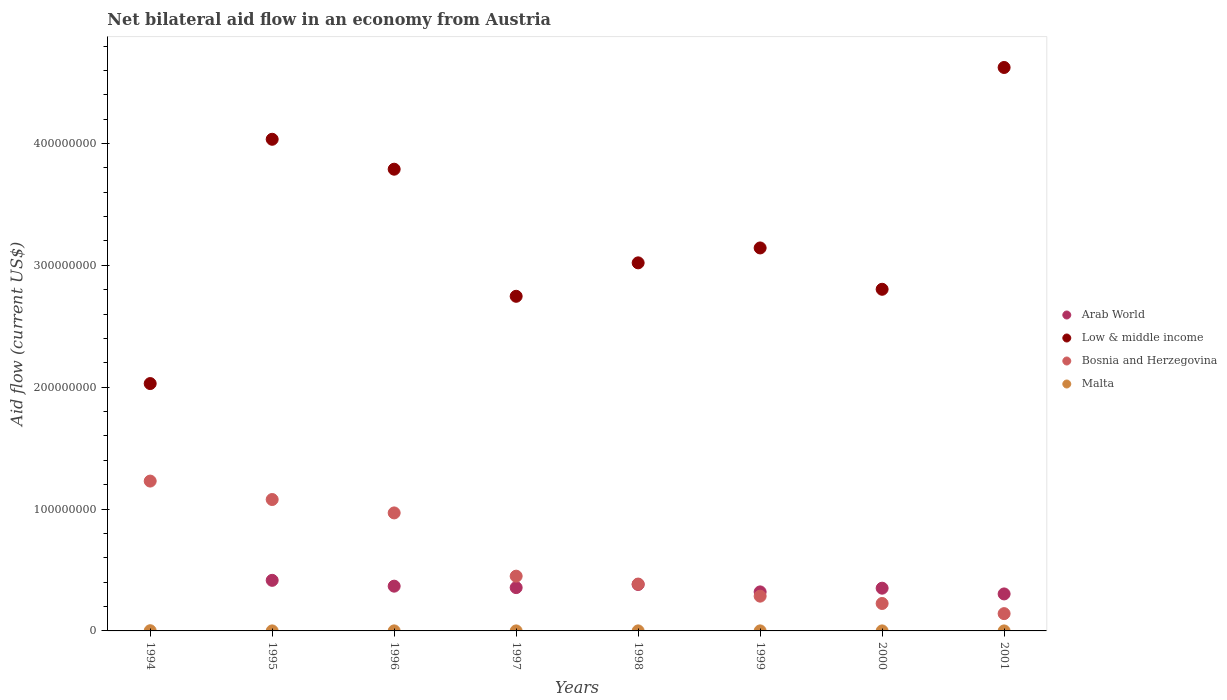What is the net bilateral aid flow in Low & middle income in 1996?
Your response must be concise. 3.79e+08. Across all years, what is the maximum net bilateral aid flow in Low & middle income?
Keep it short and to the point. 4.62e+08. Across all years, what is the minimum net bilateral aid flow in Low & middle income?
Your answer should be compact. 2.03e+08. What is the total net bilateral aid flow in Malta in the graph?
Offer a very short reply. 3.30e+05. What is the difference between the net bilateral aid flow in Malta in 1994 and that in 2001?
Offer a terse response. 1.50e+05. What is the difference between the net bilateral aid flow in Bosnia and Herzegovina in 1997 and the net bilateral aid flow in Low & middle income in 1995?
Your response must be concise. -3.59e+08. What is the average net bilateral aid flow in Low & middle income per year?
Your answer should be very brief. 3.27e+08. In the year 1996, what is the difference between the net bilateral aid flow in Malta and net bilateral aid flow in Bosnia and Herzegovina?
Give a very brief answer. -9.68e+07. What is the ratio of the net bilateral aid flow in Low & middle income in 1996 to that in 1997?
Your answer should be compact. 1.38. Is the net bilateral aid flow in Malta in 1999 less than that in 2000?
Your response must be concise. No. What is the difference between the highest and the second highest net bilateral aid flow in Bosnia and Herzegovina?
Give a very brief answer. 1.51e+07. What is the difference between the highest and the lowest net bilateral aid flow in Malta?
Provide a succinct answer. 1.50e+05. Is it the case that in every year, the sum of the net bilateral aid flow in Low & middle income and net bilateral aid flow in Bosnia and Herzegovina  is greater than the net bilateral aid flow in Malta?
Make the answer very short. Yes. What is the title of the graph?
Ensure brevity in your answer.  Net bilateral aid flow in an economy from Austria. What is the label or title of the X-axis?
Keep it short and to the point. Years. What is the Aid flow (current US$) of Low & middle income in 1994?
Keep it short and to the point. 2.03e+08. What is the Aid flow (current US$) of Bosnia and Herzegovina in 1994?
Make the answer very short. 1.23e+08. What is the Aid flow (current US$) of Malta in 1994?
Offer a terse response. 1.60e+05. What is the Aid flow (current US$) of Arab World in 1995?
Keep it short and to the point. 4.15e+07. What is the Aid flow (current US$) in Low & middle income in 1995?
Provide a short and direct response. 4.03e+08. What is the Aid flow (current US$) in Bosnia and Herzegovina in 1995?
Your answer should be very brief. 1.08e+08. What is the Aid flow (current US$) of Malta in 1995?
Your answer should be very brief. 2.00e+04. What is the Aid flow (current US$) of Arab World in 1996?
Your answer should be very brief. 3.67e+07. What is the Aid flow (current US$) of Low & middle income in 1996?
Keep it short and to the point. 3.79e+08. What is the Aid flow (current US$) of Bosnia and Herzegovina in 1996?
Ensure brevity in your answer.  9.68e+07. What is the Aid flow (current US$) of Arab World in 1997?
Offer a very short reply. 3.56e+07. What is the Aid flow (current US$) in Low & middle income in 1997?
Your answer should be very brief. 2.75e+08. What is the Aid flow (current US$) of Bosnia and Herzegovina in 1997?
Provide a succinct answer. 4.49e+07. What is the Aid flow (current US$) in Malta in 1997?
Provide a succinct answer. 2.00e+04. What is the Aid flow (current US$) of Arab World in 1998?
Give a very brief answer. 3.81e+07. What is the Aid flow (current US$) of Low & middle income in 1998?
Your answer should be very brief. 3.02e+08. What is the Aid flow (current US$) of Bosnia and Herzegovina in 1998?
Your answer should be very brief. 3.85e+07. What is the Aid flow (current US$) of Arab World in 1999?
Provide a succinct answer. 3.20e+07. What is the Aid flow (current US$) of Low & middle income in 1999?
Make the answer very short. 3.14e+08. What is the Aid flow (current US$) in Bosnia and Herzegovina in 1999?
Your answer should be compact. 2.85e+07. What is the Aid flow (current US$) in Arab World in 2000?
Ensure brevity in your answer.  3.51e+07. What is the Aid flow (current US$) of Low & middle income in 2000?
Offer a very short reply. 2.80e+08. What is the Aid flow (current US$) of Bosnia and Herzegovina in 2000?
Give a very brief answer. 2.25e+07. What is the Aid flow (current US$) in Malta in 2000?
Offer a terse response. 2.00e+04. What is the Aid flow (current US$) of Arab World in 2001?
Offer a terse response. 3.04e+07. What is the Aid flow (current US$) in Low & middle income in 2001?
Provide a succinct answer. 4.62e+08. What is the Aid flow (current US$) of Bosnia and Herzegovina in 2001?
Offer a terse response. 1.42e+07. What is the Aid flow (current US$) in Malta in 2001?
Offer a very short reply. 10000. Across all years, what is the maximum Aid flow (current US$) of Arab World?
Keep it short and to the point. 4.15e+07. Across all years, what is the maximum Aid flow (current US$) of Low & middle income?
Offer a terse response. 4.62e+08. Across all years, what is the maximum Aid flow (current US$) in Bosnia and Herzegovina?
Your answer should be compact. 1.23e+08. Across all years, what is the maximum Aid flow (current US$) in Malta?
Offer a terse response. 1.60e+05. Across all years, what is the minimum Aid flow (current US$) in Low & middle income?
Your answer should be compact. 2.03e+08. Across all years, what is the minimum Aid flow (current US$) of Bosnia and Herzegovina?
Your response must be concise. 1.42e+07. Across all years, what is the minimum Aid flow (current US$) in Malta?
Your answer should be compact. 10000. What is the total Aid flow (current US$) in Arab World in the graph?
Provide a succinct answer. 2.49e+08. What is the total Aid flow (current US$) of Low & middle income in the graph?
Provide a succinct answer. 2.62e+09. What is the total Aid flow (current US$) of Bosnia and Herzegovina in the graph?
Give a very brief answer. 4.76e+08. What is the difference between the Aid flow (current US$) of Low & middle income in 1994 and that in 1995?
Make the answer very short. -2.00e+08. What is the difference between the Aid flow (current US$) in Bosnia and Herzegovina in 1994 and that in 1995?
Provide a succinct answer. 1.51e+07. What is the difference between the Aid flow (current US$) in Low & middle income in 1994 and that in 1996?
Your answer should be very brief. -1.76e+08. What is the difference between the Aid flow (current US$) of Bosnia and Herzegovina in 1994 and that in 1996?
Offer a very short reply. 2.61e+07. What is the difference between the Aid flow (current US$) of Malta in 1994 and that in 1996?
Make the answer very short. 1.20e+05. What is the difference between the Aid flow (current US$) in Low & middle income in 1994 and that in 1997?
Provide a succinct answer. -7.16e+07. What is the difference between the Aid flow (current US$) of Bosnia and Herzegovina in 1994 and that in 1997?
Offer a terse response. 7.80e+07. What is the difference between the Aid flow (current US$) of Low & middle income in 1994 and that in 1998?
Your response must be concise. -9.91e+07. What is the difference between the Aid flow (current US$) in Bosnia and Herzegovina in 1994 and that in 1998?
Your response must be concise. 8.45e+07. What is the difference between the Aid flow (current US$) in Malta in 1994 and that in 1998?
Offer a terse response. 1.30e+05. What is the difference between the Aid flow (current US$) of Low & middle income in 1994 and that in 1999?
Your answer should be compact. -1.11e+08. What is the difference between the Aid flow (current US$) of Bosnia and Herzegovina in 1994 and that in 1999?
Offer a terse response. 9.44e+07. What is the difference between the Aid flow (current US$) in Low & middle income in 1994 and that in 2000?
Provide a short and direct response. -7.74e+07. What is the difference between the Aid flow (current US$) in Bosnia and Herzegovina in 1994 and that in 2000?
Your answer should be very brief. 1.00e+08. What is the difference between the Aid flow (current US$) of Malta in 1994 and that in 2000?
Offer a very short reply. 1.40e+05. What is the difference between the Aid flow (current US$) of Low & middle income in 1994 and that in 2001?
Offer a terse response. -2.59e+08. What is the difference between the Aid flow (current US$) in Bosnia and Herzegovina in 1994 and that in 2001?
Ensure brevity in your answer.  1.09e+08. What is the difference between the Aid flow (current US$) of Malta in 1994 and that in 2001?
Provide a short and direct response. 1.50e+05. What is the difference between the Aid flow (current US$) in Arab World in 1995 and that in 1996?
Give a very brief answer. 4.78e+06. What is the difference between the Aid flow (current US$) in Low & middle income in 1995 and that in 1996?
Offer a very short reply. 2.46e+07. What is the difference between the Aid flow (current US$) of Bosnia and Herzegovina in 1995 and that in 1996?
Provide a short and direct response. 1.10e+07. What is the difference between the Aid flow (current US$) of Malta in 1995 and that in 1996?
Your response must be concise. -2.00e+04. What is the difference between the Aid flow (current US$) of Arab World in 1995 and that in 1997?
Ensure brevity in your answer.  5.96e+06. What is the difference between the Aid flow (current US$) of Low & middle income in 1995 and that in 1997?
Your response must be concise. 1.29e+08. What is the difference between the Aid flow (current US$) in Bosnia and Herzegovina in 1995 and that in 1997?
Keep it short and to the point. 6.29e+07. What is the difference between the Aid flow (current US$) of Arab World in 1995 and that in 1998?
Keep it short and to the point. 3.39e+06. What is the difference between the Aid flow (current US$) in Low & middle income in 1995 and that in 1998?
Ensure brevity in your answer.  1.01e+08. What is the difference between the Aid flow (current US$) of Bosnia and Herzegovina in 1995 and that in 1998?
Your answer should be compact. 6.94e+07. What is the difference between the Aid flow (current US$) of Malta in 1995 and that in 1998?
Keep it short and to the point. -10000. What is the difference between the Aid flow (current US$) in Arab World in 1995 and that in 1999?
Give a very brief answer. 9.48e+06. What is the difference between the Aid flow (current US$) of Low & middle income in 1995 and that in 1999?
Give a very brief answer. 8.92e+07. What is the difference between the Aid flow (current US$) of Bosnia and Herzegovina in 1995 and that in 1999?
Ensure brevity in your answer.  7.93e+07. What is the difference between the Aid flow (current US$) of Arab World in 1995 and that in 2000?
Offer a very short reply. 6.44e+06. What is the difference between the Aid flow (current US$) in Low & middle income in 1995 and that in 2000?
Give a very brief answer. 1.23e+08. What is the difference between the Aid flow (current US$) in Bosnia and Herzegovina in 1995 and that in 2000?
Ensure brevity in your answer.  8.53e+07. What is the difference between the Aid flow (current US$) in Malta in 1995 and that in 2000?
Your answer should be compact. 0. What is the difference between the Aid flow (current US$) of Arab World in 1995 and that in 2001?
Offer a very short reply. 1.12e+07. What is the difference between the Aid flow (current US$) of Low & middle income in 1995 and that in 2001?
Make the answer very short. -5.89e+07. What is the difference between the Aid flow (current US$) in Bosnia and Herzegovina in 1995 and that in 2001?
Make the answer very short. 9.36e+07. What is the difference between the Aid flow (current US$) of Arab World in 1996 and that in 1997?
Provide a short and direct response. 1.18e+06. What is the difference between the Aid flow (current US$) in Low & middle income in 1996 and that in 1997?
Your answer should be compact. 1.04e+08. What is the difference between the Aid flow (current US$) of Bosnia and Herzegovina in 1996 and that in 1997?
Give a very brief answer. 5.19e+07. What is the difference between the Aid flow (current US$) in Malta in 1996 and that in 1997?
Offer a very short reply. 2.00e+04. What is the difference between the Aid flow (current US$) in Arab World in 1996 and that in 1998?
Give a very brief answer. -1.39e+06. What is the difference between the Aid flow (current US$) of Low & middle income in 1996 and that in 1998?
Give a very brief answer. 7.69e+07. What is the difference between the Aid flow (current US$) in Bosnia and Herzegovina in 1996 and that in 1998?
Make the answer very short. 5.84e+07. What is the difference between the Aid flow (current US$) in Arab World in 1996 and that in 1999?
Make the answer very short. 4.70e+06. What is the difference between the Aid flow (current US$) in Low & middle income in 1996 and that in 1999?
Offer a terse response. 6.46e+07. What is the difference between the Aid flow (current US$) in Bosnia and Herzegovina in 1996 and that in 1999?
Your answer should be very brief. 6.83e+07. What is the difference between the Aid flow (current US$) of Arab World in 1996 and that in 2000?
Provide a short and direct response. 1.66e+06. What is the difference between the Aid flow (current US$) in Low & middle income in 1996 and that in 2000?
Make the answer very short. 9.85e+07. What is the difference between the Aid flow (current US$) of Bosnia and Herzegovina in 1996 and that in 2000?
Make the answer very short. 7.43e+07. What is the difference between the Aid flow (current US$) of Malta in 1996 and that in 2000?
Offer a very short reply. 2.00e+04. What is the difference between the Aid flow (current US$) in Arab World in 1996 and that in 2001?
Keep it short and to the point. 6.37e+06. What is the difference between the Aid flow (current US$) in Low & middle income in 1996 and that in 2001?
Keep it short and to the point. -8.35e+07. What is the difference between the Aid flow (current US$) of Bosnia and Herzegovina in 1996 and that in 2001?
Offer a terse response. 8.26e+07. What is the difference between the Aid flow (current US$) of Arab World in 1997 and that in 1998?
Provide a succinct answer. -2.57e+06. What is the difference between the Aid flow (current US$) in Low & middle income in 1997 and that in 1998?
Provide a succinct answer. -2.74e+07. What is the difference between the Aid flow (current US$) of Bosnia and Herzegovina in 1997 and that in 1998?
Offer a very short reply. 6.48e+06. What is the difference between the Aid flow (current US$) in Arab World in 1997 and that in 1999?
Keep it short and to the point. 3.52e+06. What is the difference between the Aid flow (current US$) of Low & middle income in 1997 and that in 1999?
Make the answer very short. -3.97e+07. What is the difference between the Aid flow (current US$) in Bosnia and Herzegovina in 1997 and that in 1999?
Ensure brevity in your answer.  1.64e+07. What is the difference between the Aid flow (current US$) of Low & middle income in 1997 and that in 2000?
Make the answer very short. -5.76e+06. What is the difference between the Aid flow (current US$) of Bosnia and Herzegovina in 1997 and that in 2000?
Make the answer very short. 2.24e+07. What is the difference between the Aid flow (current US$) in Malta in 1997 and that in 2000?
Your answer should be very brief. 0. What is the difference between the Aid flow (current US$) in Arab World in 1997 and that in 2001?
Provide a short and direct response. 5.19e+06. What is the difference between the Aid flow (current US$) in Low & middle income in 1997 and that in 2001?
Provide a short and direct response. -1.88e+08. What is the difference between the Aid flow (current US$) in Bosnia and Herzegovina in 1997 and that in 2001?
Offer a very short reply. 3.08e+07. What is the difference between the Aid flow (current US$) of Arab World in 1998 and that in 1999?
Make the answer very short. 6.09e+06. What is the difference between the Aid flow (current US$) in Low & middle income in 1998 and that in 1999?
Your answer should be compact. -1.22e+07. What is the difference between the Aid flow (current US$) of Bosnia and Herzegovina in 1998 and that in 1999?
Your response must be concise. 9.93e+06. What is the difference between the Aid flow (current US$) of Malta in 1998 and that in 1999?
Your answer should be very brief. 0. What is the difference between the Aid flow (current US$) of Arab World in 1998 and that in 2000?
Make the answer very short. 3.05e+06. What is the difference between the Aid flow (current US$) of Low & middle income in 1998 and that in 2000?
Make the answer very short. 2.17e+07. What is the difference between the Aid flow (current US$) of Bosnia and Herzegovina in 1998 and that in 2000?
Give a very brief answer. 1.59e+07. What is the difference between the Aid flow (current US$) of Malta in 1998 and that in 2000?
Give a very brief answer. 10000. What is the difference between the Aid flow (current US$) in Arab World in 1998 and that in 2001?
Ensure brevity in your answer.  7.76e+06. What is the difference between the Aid flow (current US$) in Low & middle income in 1998 and that in 2001?
Your answer should be compact. -1.60e+08. What is the difference between the Aid flow (current US$) in Bosnia and Herzegovina in 1998 and that in 2001?
Give a very brief answer. 2.43e+07. What is the difference between the Aid flow (current US$) in Malta in 1998 and that in 2001?
Provide a succinct answer. 2.00e+04. What is the difference between the Aid flow (current US$) of Arab World in 1999 and that in 2000?
Provide a short and direct response. -3.04e+06. What is the difference between the Aid flow (current US$) of Low & middle income in 1999 and that in 2000?
Your answer should be very brief. 3.39e+07. What is the difference between the Aid flow (current US$) of Bosnia and Herzegovina in 1999 and that in 2000?
Give a very brief answer. 6.01e+06. What is the difference between the Aid flow (current US$) of Malta in 1999 and that in 2000?
Ensure brevity in your answer.  10000. What is the difference between the Aid flow (current US$) of Arab World in 1999 and that in 2001?
Ensure brevity in your answer.  1.67e+06. What is the difference between the Aid flow (current US$) in Low & middle income in 1999 and that in 2001?
Give a very brief answer. -1.48e+08. What is the difference between the Aid flow (current US$) of Bosnia and Herzegovina in 1999 and that in 2001?
Provide a succinct answer. 1.43e+07. What is the difference between the Aid flow (current US$) in Arab World in 2000 and that in 2001?
Provide a short and direct response. 4.71e+06. What is the difference between the Aid flow (current US$) of Low & middle income in 2000 and that in 2001?
Make the answer very short. -1.82e+08. What is the difference between the Aid flow (current US$) in Bosnia and Herzegovina in 2000 and that in 2001?
Keep it short and to the point. 8.33e+06. What is the difference between the Aid flow (current US$) in Malta in 2000 and that in 2001?
Ensure brevity in your answer.  10000. What is the difference between the Aid flow (current US$) in Low & middle income in 1994 and the Aid flow (current US$) in Bosnia and Herzegovina in 1995?
Provide a short and direct response. 9.52e+07. What is the difference between the Aid flow (current US$) in Low & middle income in 1994 and the Aid flow (current US$) in Malta in 1995?
Give a very brief answer. 2.03e+08. What is the difference between the Aid flow (current US$) of Bosnia and Herzegovina in 1994 and the Aid flow (current US$) of Malta in 1995?
Make the answer very short. 1.23e+08. What is the difference between the Aid flow (current US$) in Low & middle income in 1994 and the Aid flow (current US$) in Bosnia and Herzegovina in 1996?
Your answer should be compact. 1.06e+08. What is the difference between the Aid flow (current US$) of Low & middle income in 1994 and the Aid flow (current US$) of Malta in 1996?
Provide a succinct answer. 2.03e+08. What is the difference between the Aid flow (current US$) in Bosnia and Herzegovina in 1994 and the Aid flow (current US$) in Malta in 1996?
Provide a succinct answer. 1.23e+08. What is the difference between the Aid flow (current US$) in Low & middle income in 1994 and the Aid flow (current US$) in Bosnia and Herzegovina in 1997?
Keep it short and to the point. 1.58e+08. What is the difference between the Aid flow (current US$) of Low & middle income in 1994 and the Aid flow (current US$) of Malta in 1997?
Your answer should be very brief. 2.03e+08. What is the difference between the Aid flow (current US$) of Bosnia and Herzegovina in 1994 and the Aid flow (current US$) of Malta in 1997?
Offer a terse response. 1.23e+08. What is the difference between the Aid flow (current US$) in Low & middle income in 1994 and the Aid flow (current US$) in Bosnia and Herzegovina in 1998?
Your response must be concise. 1.65e+08. What is the difference between the Aid flow (current US$) in Low & middle income in 1994 and the Aid flow (current US$) in Malta in 1998?
Offer a terse response. 2.03e+08. What is the difference between the Aid flow (current US$) of Bosnia and Herzegovina in 1994 and the Aid flow (current US$) of Malta in 1998?
Provide a short and direct response. 1.23e+08. What is the difference between the Aid flow (current US$) in Low & middle income in 1994 and the Aid flow (current US$) in Bosnia and Herzegovina in 1999?
Your answer should be compact. 1.74e+08. What is the difference between the Aid flow (current US$) in Low & middle income in 1994 and the Aid flow (current US$) in Malta in 1999?
Your response must be concise. 2.03e+08. What is the difference between the Aid flow (current US$) in Bosnia and Herzegovina in 1994 and the Aid flow (current US$) in Malta in 1999?
Give a very brief answer. 1.23e+08. What is the difference between the Aid flow (current US$) in Low & middle income in 1994 and the Aid flow (current US$) in Bosnia and Herzegovina in 2000?
Offer a terse response. 1.80e+08. What is the difference between the Aid flow (current US$) of Low & middle income in 1994 and the Aid flow (current US$) of Malta in 2000?
Your answer should be very brief. 2.03e+08. What is the difference between the Aid flow (current US$) of Bosnia and Herzegovina in 1994 and the Aid flow (current US$) of Malta in 2000?
Offer a terse response. 1.23e+08. What is the difference between the Aid flow (current US$) of Low & middle income in 1994 and the Aid flow (current US$) of Bosnia and Herzegovina in 2001?
Provide a succinct answer. 1.89e+08. What is the difference between the Aid flow (current US$) of Low & middle income in 1994 and the Aid flow (current US$) of Malta in 2001?
Provide a short and direct response. 2.03e+08. What is the difference between the Aid flow (current US$) in Bosnia and Herzegovina in 1994 and the Aid flow (current US$) in Malta in 2001?
Your answer should be very brief. 1.23e+08. What is the difference between the Aid flow (current US$) of Arab World in 1995 and the Aid flow (current US$) of Low & middle income in 1996?
Provide a short and direct response. -3.37e+08. What is the difference between the Aid flow (current US$) in Arab World in 1995 and the Aid flow (current US$) in Bosnia and Herzegovina in 1996?
Provide a succinct answer. -5.53e+07. What is the difference between the Aid flow (current US$) of Arab World in 1995 and the Aid flow (current US$) of Malta in 1996?
Keep it short and to the point. 4.15e+07. What is the difference between the Aid flow (current US$) in Low & middle income in 1995 and the Aid flow (current US$) in Bosnia and Herzegovina in 1996?
Your answer should be very brief. 3.07e+08. What is the difference between the Aid flow (current US$) in Low & middle income in 1995 and the Aid flow (current US$) in Malta in 1996?
Give a very brief answer. 4.03e+08. What is the difference between the Aid flow (current US$) in Bosnia and Herzegovina in 1995 and the Aid flow (current US$) in Malta in 1996?
Your answer should be compact. 1.08e+08. What is the difference between the Aid flow (current US$) of Arab World in 1995 and the Aid flow (current US$) of Low & middle income in 1997?
Your answer should be compact. -2.33e+08. What is the difference between the Aid flow (current US$) of Arab World in 1995 and the Aid flow (current US$) of Bosnia and Herzegovina in 1997?
Make the answer very short. -3.43e+06. What is the difference between the Aid flow (current US$) of Arab World in 1995 and the Aid flow (current US$) of Malta in 1997?
Give a very brief answer. 4.15e+07. What is the difference between the Aid flow (current US$) of Low & middle income in 1995 and the Aid flow (current US$) of Bosnia and Herzegovina in 1997?
Your answer should be compact. 3.59e+08. What is the difference between the Aid flow (current US$) in Low & middle income in 1995 and the Aid flow (current US$) in Malta in 1997?
Offer a terse response. 4.03e+08. What is the difference between the Aid flow (current US$) of Bosnia and Herzegovina in 1995 and the Aid flow (current US$) of Malta in 1997?
Keep it short and to the point. 1.08e+08. What is the difference between the Aid flow (current US$) in Arab World in 1995 and the Aid flow (current US$) in Low & middle income in 1998?
Offer a very short reply. -2.61e+08. What is the difference between the Aid flow (current US$) of Arab World in 1995 and the Aid flow (current US$) of Bosnia and Herzegovina in 1998?
Provide a short and direct response. 3.05e+06. What is the difference between the Aid flow (current US$) in Arab World in 1995 and the Aid flow (current US$) in Malta in 1998?
Give a very brief answer. 4.15e+07. What is the difference between the Aid flow (current US$) in Low & middle income in 1995 and the Aid flow (current US$) in Bosnia and Herzegovina in 1998?
Make the answer very short. 3.65e+08. What is the difference between the Aid flow (current US$) of Low & middle income in 1995 and the Aid flow (current US$) of Malta in 1998?
Ensure brevity in your answer.  4.03e+08. What is the difference between the Aid flow (current US$) in Bosnia and Herzegovina in 1995 and the Aid flow (current US$) in Malta in 1998?
Offer a very short reply. 1.08e+08. What is the difference between the Aid flow (current US$) of Arab World in 1995 and the Aid flow (current US$) of Low & middle income in 1999?
Give a very brief answer. -2.73e+08. What is the difference between the Aid flow (current US$) in Arab World in 1995 and the Aid flow (current US$) in Bosnia and Herzegovina in 1999?
Keep it short and to the point. 1.30e+07. What is the difference between the Aid flow (current US$) of Arab World in 1995 and the Aid flow (current US$) of Malta in 1999?
Your answer should be compact. 4.15e+07. What is the difference between the Aid flow (current US$) of Low & middle income in 1995 and the Aid flow (current US$) of Bosnia and Herzegovina in 1999?
Give a very brief answer. 3.75e+08. What is the difference between the Aid flow (current US$) in Low & middle income in 1995 and the Aid flow (current US$) in Malta in 1999?
Keep it short and to the point. 4.03e+08. What is the difference between the Aid flow (current US$) of Bosnia and Herzegovina in 1995 and the Aid flow (current US$) of Malta in 1999?
Ensure brevity in your answer.  1.08e+08. What is the difference between the Aid flow (current US$) in Arab World in 1995 and the Aid flow (current US$) in Low & middle income in 2000?
Ensure brevity in your answer.  -2.39e+08. What is the difference between the Aid flow (current US$) of Arab World in 1995 and the Aid flow (current US$) of Bosnia and Herzegovina in 2000?
Provide a short and direct response. 1.90e+07. What is the difference between the Aid flow (current US$) of Arab World in 1995 and the Aid flow (current US$) of Malta in 2000?
Ensure brevity in your answer.  4.15e+07. What is the difference between the Aid flow (current US$) in Low & middle income in 1995 and the Aid flow (current US$) in Bosnia and Herzegovina in 2000?
Offer a terse response. 3.81e+08. What is the difference between the Aid flow (current US$) of Low & middle income in 1995 and the Aid flow (current US$) of Malta in 2000?
Ensure brevity in your answer.  4.03e+08. What is the difference between the Aid flow (current US$) of Bosnia and Herzegovina in 1995 and the Aid flow (current US$) of Malta in 2000?
Offer a very short reply. 1.08e+08. What is the difference between the Aid flow (current US$) of Arab World in 1995 and the Aid flow (current US$) of Low & middle income in 2001?
Offer a terse response. -4.21e+08. What is the difference between the Aid flow (current US$) in Arab World in 1995 and the Aid flow (current US$) in Bosnia and Herzegovina in 2001?
Keep it short and to the point. 2.73e+07. What is the difference between the Aid flow (current US$) in Arab World in 1995 and the Aid flow (current US$) in Malta in 2001?
Provide a short and direct response. 4.15e+07. What is the difference between the Aid flow (current US$) in Low & middle income in 1995 and the Aid flow (current US$) in Bosnia and Herzegovina in 2001?
Ensure brevity in your answer.  3.89e+08. What is the difference between the Aid flow (current US$) of Low & middle income in 1995 and the Aid flow (current US$) of Malta in 2001?
Your response must be concise. 4.03e+08. What is the difference between the Aid flow (current US$) in Bosnia and Herzegovina in 1995 and the Aid flow (current US$) in Malta in 2001?
Your answer should be very brief. 1.08e+08. What is the difference between the Aid flow (current US$) in Arab World in 1996 and the Aid flow (current US$) in Low & middle income in 1997?
Give a very brief answer. -2.38e+08. What is the difference between the Aid flow (current US$) in Arab World in 1996 and the Aid flow (current US$) in Bosnia and Herzegovina in 1997?
Your answer should be compact. -8.21e+06. What is the difference between the Aid flow (current US$) in Arab World in 1996 and the Aid flow (current US$) in Malta in 1997?
Provide a succinct answer. 3.67e+07. What is the difference between the Aid flow (current US$) in Low & middle income in 1996 and the Aid flow (current US$) in Bosnia and Herzegovina in 1997?
Your response must be concise. 3.34e+08. What is the difference between the Aid flow (current US$) of Low & middle income in 1996 and the Aid flow (current US$) of Malta in 1997?
Keep it short and to the point. 3.79e+08. What is the difference between the Aid flow (current US$) in Bosnia and Herzegovina in 1996 and the Aid flow (current US$) in Malta in 1997?
Give a very brief answer. 9.68e+07. What is the difference between the Aid flow (current US$) of Arab World in 1996 and the Aid flow (current US$) of Low & middle income in 1998?
Your response must be concise. -2.65e+08. What is the difference between the Aid flow (current US$) in Arab World in 1996 and the Aid flow (current US$) in Bosnia and Herzegovina in 1998?
Offer a terse response. -1.73e+06. What is the difference between the Aid flow (current US$) in Arab World in 1996 and the Aid flow (current US$) in Malta in 1998?
Make the answer very short. 3.67e+07. What is the difference between the Aid flow (current US$) of Low & middle income in 1996 and the Aid flow (current US$) of Bosnia and Herzegovina in 1998?
Keep it short and to the point. 3.40e+08. What is the difference between the Aid flow (current US$) of Low & middle income in 1996 and the Aid flow (current US$) of Malta in 1998?
Provide a succinct answer. 3.79e+08. What is the difference between the Aid flow (current US$) of Bosnia and Herzegovina in 1996 and the Aid flow (current US$) of Malta in 1998?
Give a very brief answer. 9.68e+07. What is the difference between the Aid flow (current US$) of Arab World in 1996 and the Aid flow (current US$) of Low & middle income in 1999?
Make the answer very short. -2.78e+08. What is the difference between the Aid flow (current US$) in Arab World in 1996 and the Aid flow (current US$) in Bosnia and Herzegovina in 1999?
Your answer should be compact. 8.20e+06. What is the difference between the Aid flow (current US$) in Arab World in 1996 and the Aid flow (current US$) in Malta in 1999?
Provide a short and direct response. 3.67e+07. What is the difference between the Aid flow (current US$) of Low & middle income in 1996 and the Aid flow (current US$) of Bosnia and Herzegovina in 1999?
Keep it short and to the point. 3.50e+08. What is the difference between the Aid flow (current US$) of Low & middle income in 1996 and the Aid flow (current US$) of Malta in 1999?
Give a very brief answer. 3.79e+08. What is the difference between the Aid flow (current US$) in Bosnia and Herzegovina in 1996 and the Aid flow (current US$) in Malta in 1999?
Ensure brevity in your answer.  9.68e+07. What is the difference between the Aid flow (current US$) of Arab World in 1996 and the Aid flow (current US$) of Low & middle income in 2000?
Your answer should be compact. -2.44e+08. What is the difference between the Aid flow (current US$) of Arab World in 1996 and the Aid flow (current US$) of Bosnia and Herzegovina in 2000?
Make the answer very short. 1.42e+07. What is the difference between the Aid flow (current US$) in Arab World in 1996 and the Aid flow (current US$) in Malta in 2000?
Offer a very short reply. 3.67e+07. What is the difference between the Aid flow (current US$) in Low & middle income in 1996 and the Aid flow (current US$) in Bosnia and Herzegovina in 2000?
Your answer should be very brief. 3.56e+08. What is the difference between the Aid flow (current US$) in Low & middle income in 1996 and the Aid flow (current US$) in Malta in 2000?
Offer a very short reply. 3.79e+08. What is the difference between the Aid flow (current US$) in Bosnia and Herzegovina in 1996 and the Aid flow (current US$) in Malta in 2000?
Give a very brief answer. 9.68e+07. What is the difference between the Aid flow (current US$) in Arab World in 1996 and the Aid flow (current US$) in Low & middle income in 2001?
Ensure brevity in your answer.  -4.26e+08. What is the difference between the Aid flow (current US$) in Arab World in 1996 and the Aid flow (current US$) in Bosnia and Herzegovina in 2001?
Provide a short and direct response. 2.25e+07. What is the difference between the Aid flow (current US$) in Arab World in 1996 and the Aid flow (current US$) in Malta in 2001?
Provide a succinct answer. 3.67e+07. What is the difference between the Aid flow (current US$) in Low & middle income in 1996 and the Aid flow (current US$) in Bosnia and Herzegovina in 2001?
Your answer should be very brief. 3.65e+08. What is the difference between the Aid flow (current US$) of Low & middle income in 1996 and the Aid flow (current US$) of Malta in 2001?
Provide a succinct answer. 3.79e+08. What is the difference between the Aid flow (current US$) of Bosnia and Herzegovina in 1996 and the Aid flow (current US$) of Malta in 2001?
Give a very brief answer. 9.68e+07. What is the difference between the Aid flow (current US$) in Arab World in 1997 and the Aid flow (current US$) in Low & middle income in 1998?
Your answer should be very brief. -2.67e+08. What is the difference between the Aid flow (current US$) in Arab World in 1997 and the Aid flow (current US$) in Bosnia and Herzegovina in 1998?
Your answer should be compact. -2.91e+06. What is the difference between the Aid flow (current US$) of Arab World in 1997 and the Aid flow (current US$) of Malta in 1998?
Offer a terse response. 3.55e+07. What is the difference between the Aid flow (current US$) in Low & middle income in 1997 and the Aid flow (current US$) in Bosnia and Herzegovina in 1998?
Your answer should be very brief. 2.36e+08. What is the difference between the Aid flow (current US$) of Low & middle income in 1997 and the Aid flow (current US$) of Malta in 1998?
Make the answer very short. 2.75e+08. What is the difference between the Aid flow (current US$) in Bosnia and Herzegovina in 1997 and the Aid flow (current US$) in Malta in 1998?
Give a very brief answer. 4.49e+07. What is the difference between the Aid flow (current US$) in Arab World in 1997 and the Aid flow (current US$) in Low & middle income in 1999?
Your answer should be very brief. -2.79e+08. What is the difference between the Aid flow (current US$) in Arab World in 1997 and the Aid flow (current US$) in Bosnia and Herzegovina in 1999?
Provide a succinct answer. 7.02e+06. What is the difference between the Aid flow (current US$) in Arab World in 1997 and the Aid flow (current US$) in Malta in 1999?
Make the answer very short. 3.55e+07. What is the difference between the Aid flow (current US$) in Low & middle income in 1997 and the Aid flow (current US$) in Bosnia and Herzegovina in 1999?
Give a very brief answer. 2.46e+08. What is the difference between the Aid flow (current US$) in Low & middle income in 1997 and the Aid flow (current US$) in Malta in 1999?
Ensure brevity in your answer.  2.75e+08. What is the difference between the Aid flow (current US$) in Bosnia and Herzegovina in 1997 and the Aid flow (current US$) in Malta in 1999?
Offer a terse response. 4.49e+07. What is the difference between the Aid flow (current US$) of Arab World in 1997 and the Aid flow (current US$) of Low & middle income in 2000?
Give a very brief answer. -2.45e+08. What is the difference between the Aid flow (current US$) in Arab World in 1997 and the Aid flow (current US$) in Bosnia and Herzegovina in 2000?
Keep it short and to the point. 1.30e+07. What is the difference between the Aid flow (current US$) in Arab World in 1997 and the Aid flow (current US$) in Malta in 2000?
Keep it short and to the point. 3.55e+07. What is the difference between the Aid flow (current US$) of Low & middle income in 1997 and the Aid flow (current US$) of Bosnia and Herzegovina in 2000?
Provide a succinct answer. 2.52e+08. What is the difference between the Aid flow (current US$) in Low & middle income in 1997 and the Aid flow (current US$) in Malta in 2000?
Your answer should be compact. 2.75e+08. What is the difference between the Aid flow (current US$) in Bosnia and Herzegovina in 1997 and the Aid flow (current US$) in Malta in 2000?
Ensure brevity in your answer.  4.49e+07. What is the difference between the Aid flow (current US$) in Arab World in 1997 and the Aid flow (current US$) in Low & middle income in 2001?
Offer a terse response. -4.27e+08. What is the difference between the Aid flow (current US$) of Arab World in 1997 and the Aid flow (current US$) of Bosnia and Herzegovina in 2001?
Provide a succinct answer. 2.14e+07. What is the difference between the Aid flow (current US$) in Arab World in 1997 and the Aid flow (current US$) in Malta in 2001?
Provide a short and direct response. 3.55e+07. What is the difference between the Aid flow (current US$) in Low & middle income in 1997 and the Aid flow (current US$) in Bosnia and Herzegovina in 2001?
Your answer should be compact. 2.60e+08. What is the difference between the Aid flow (current US$) in Low & middle income in 1997 and the Aid flow (current US$) in Malta in 2001?
Keep it short and to the point. 2.75e+08. What is the difference between the Aid flow (current US$) in Bosnia and Herzegovina in 1997 and the Aid flow (current US$) in Malta in 2001?
Offer a terse response. 4.49e+07. What is the difference between the Aid flow (current US$) in Arab World in 1998 and the Aid flow (current US$) in Low & middle income in 1999?
Provide a succinct answer. -2.76e+08. What is the difference between the Aid flow (current US$) of Arab World in 1998 and the Aid flow (current US$) of Bosnia and Herzegovina in 1999?
Ensure brevity in your answer.  9.59e+06. What is the difference between the Aid flow (current US$) of Arab World in 1998 and the Aid flow (current US$) of Malta in 1999?
Offer a terse response. 3.81e+07. What is the difference between the Aid flow (current US$) of Low & middle income in 1998 and the Aid flow (current US$) of Bosnia and Herzegovina in 1999?
Your response must be concise. 2.74e+08. What is the difference between the Aid flow (current US$) in Low & middle income in 1998 and the Aid flow (current US$) in Malta in 1999?
Your answer should be very brief. 3.02e+08. What is the difference between the Aid flow (current US$) in Bosnia and Herzegovina in 1998 and the Aid flow (current US$) in Malta in 1999?
Your answer should be compact. 3.84e+07. What is the difference between the Aid flow (current US$) of Arab World in 1998 and the Aid flow (current US$) of Low & middle income in 2000?
Offer a very short reply. -2.42e+08. What is the difference between the Aid flow (current US$) of Arab World in 1998 and the Aid flow (current US$) of Bosnia and Herzegovina in 2000?
Your response must be concise. 1.56e+07. What is the difference between the Aid flow (current US$) in Arab World in 1998 and the Aid flow (current US$) in Malta in 2000?
Provide a short and direct response. 3.81e+07. What is the difference between the Aid flow (current US$) of Low & middle income in 1998 and the Aid flow (current US$) of Bosnia and Herzegovina in 2000?
Your response must be concise. 2.80e+08. What is the difference between the Aid flow (current US$) in Low & middle income in 1998 and the Aid flow (current US$) in Malta in 2000?
Your answer should be compact. 3.02e+08. What is the difference between the Aid flow (current US$) in Bosnia and Herzegovina in 1998 and the Aid flow (current US$) in Malta in 2000?
Your answer should be compact. 3.84e+07. What is the difference between the Aid flow (current US$) of Arab World in 1998 and the Aid flow (current US$) of Low & middle income in 2001?
Give a very brief answer. -4.24e+08. What is the difference between the Aid flow (current US$) in Arab World in 1998 and the Aid flow (current US$) in Bosnia and Herzegovina in 2001?
Your answer should be compact. 2.39e+07. What is the difference between the Aid flow (current US$) of Arab World in 1998 and the Aid flow (current US$) of Malta in 2001?
Your answer should be very brief. 3.81e+07. What is the difference between the Aid flow (current US$) in Low & middle income in 1998 and the Aid flow (current US$) in Bosnia and Herzegovina in 2001?
Give a very brief answer. 2.88e+08. What is the difference between the Aid flow (current US$) in Low & middle income in 1998 and the Aid flow (current US$) in Malta in 2001?
Offer a very short reply. 3.02e+08. What is the difference between the Aid flow (current US$) in Bosnia and Herzegovina in 1998 and the Aid flow (current US$) in Malta in 2001?
Ensure brevity in your answer.  3.84e+07. What is the difference between the Aid flow (current US$) of Arab World in 1999 and the Aid flow (current US$) of Low & middle income in 2000?
Your response must be concise. -2.48e+08. What is the difference between the Aid flow (current US$) in Arab World in 1999 and the Aid flow (current US$) in Bosnia and Herzegovina in 2000?
Offer a very short reply. 9.51e+06. What is the difference between the Aid flow (current US$) of Arab World in 1999 and the Aid flow (current US$) of Malta in 2000?
Offer a terse response. 3.20e+07. What is the difference between the Aid flow (current US$) in Low & middle income in 1999 and the Aid flow (current US$) in Bosnia and Herzegovina in 2000?
Keep it short and to the point. 2.92e+08. What is the difference between the Aid flow (current US$) in Low & middle income in 1999 and the Aid flow (current US$) in Malta in 2000?
Keep it short and to the point. 3.14e+08. What is the difference between the Aid flow (current US$) of Bosnia and Herzegovina in 1999 and the Aid flow (current US$) of Malta in 2000?
Give a very brief answer. 2.85e+07. What is the difference between the Aid flow (current US$) in Arab World in 1999 and the Aid flow (current US$) in Low & middle income in 2001?
Provide a succinct answer. -4.30e+08. What is the difference between the Aid flow (current US$) in Arab World in 1999 and the Aid flow (current US$) in Bosnia and Herzegovina in 2001?
Your answer should be compact. 1.78e+07. What is the difference between the Aid flow (current US$) in Arab World in 1999 and the Aid flow (current US$) in Malta in 2001?
Your response must be concise. 3.20e+07. What is the difference between the Aid flow (current US$) in Low & middle income in 1999 and the Aid flow (current US$) in Bosnia and Herzegovina in 2001?
Your response must be concise. 3.00e+08. What is the difference between the Aid flow (current US$) of Low & middle income in 1999 and the Aid flow (current US$) of Malta in 2001?
Offer a terse response. 3.14e+08. What is the difference between the Aid flow (current US$) of Bosnia and Herzegovina in 1999 and the Aid flow (current US$) of Malta in 2001?
Make the answer very short. 2.85e+07. What is the difference between the Aid flow (current US$) of Arab World in 2000 and the Aid flow (current US$) of Low & middle income in 2001?
Your answer should be compact. -4.27e+08. What is the difference between the Aid flow (current US$) in Arab World in 2000 and the Aid flow (current US$) in Bosnia and Herzegovina in 2001?
Provide a short and direct response. 2.09e+07. What is the difference between the Aid flow (current US$) of Arab World in 2000 and the Aid flow (current US$) of Malta in 2001?
Provide a short and direct response. 3.51e+07. What is the difference between the Aid flow (current US$) in Low & middle income in 2000 and the Aid flow (current US$) in Bosnia and Herzegovina in 2001?
Give a very brief answer. 2.66e+08. What is the difference between the Aid flow (current US$) in Low & middle income in 2000 and the Aid flow (current US$) in Malta in 2001?
Your answer should be very brief. 2.80e+08. What is the difference between the Aid flow (current US$) in Bosnia and Herzegovina in 2000 and the Aid flow (current US$) in Malta in 2001?
Provide a succinct answer. 2.25e+07. What is the average Aid flow (current US$) in Arab World per year?
Offer a terse response. 3.12e+07. What is the average Aid flow (current US$) in Low & middle income per year?
Ensure brevity in your answer.  3.27e+08. What is the average Aid flow (current US$) in Bosnia and Herzegovina per year?
Your answer should be compact. 5.95e+07. What is the average Aid flow (current US$) in Malta per year?
Keep it short and to the point. 4.12e+04. In the year 1994, what is the difference between the Aid flow (current US$) in Low & middle income and Aid flow (current US$) in Bosnia and Herzegovina?
Provide a succinct answer. 8.00e+07. In the year 1994, what is the difference between the Aid flow (current US$) of Low & middle income and Aid flow (current US$) of Malta?
Offer a very short reply. 2.03e+08. In the year 1994, what is the difference between the Aid flow (current US$) in Bosnia and Herzegovina and Aid flow (current US$) in Malta?
Give a very brief answer. 1.23e+08. In the year 1995, what is the difference between the Aid flow (current US$) of Arab World and Aid flow (current US$) of Low & middle income?
Offer a very short reply. -3.62e+08. In the year 1995, what is the difference between the Aid flow (current US$) of Arab World and Aid flow (current US$) of Bosnia and Herzegovina?
Give a very brief answer. -6.63e+07. In the year 1995, what is the difference between the Aid flow (current US$) of Arab World and Aid flow (current US$) of Malta?
Offer a terse response. 4.15e+07. In the year 1995, what is the difference between the Aid flow (current US$) of Low & middle income and Aid flow (current US$) of Bosnia and Herzegovina?
Keep it short and to the point. 2.96e+08. In the year 1995, what is the difference between the Aid flow (current US$) of Low & middle income and Aid flow (current US$) of Malta?
Keep it short and to the point. 4.03e+08. In the year 1995, what is the difference between the Aid flow (current US$) of Bosnia and Herzegovina and Aid flow (current US$) of Malta?
Keep it short and to the point. 1.08e+08. In the year 1996, what is the difference between the Aid flow (current US$) in Arab World and Aid flow (current US$) in Low & middle income?
Keep it short and to the point. -3.42e+08. In the year 1996, what is the difference between the Aid flow (current US$) in Arab World and Aid flow (current US$) in Bosnia and Herzegovina?
Ensure brevity in your answer.  -6.01e+07. In the year 1996, what is the difference between the Aid flow (current US$) of Arab World and Aid flow (current US$) of Malta?
Make the answer very short. 3.67e+07. In the year 1996, what is the difference between the Aid flow (current US$) in Low & middle income and Aid flow (current US$) in Bosnia and Herzegovina?
Your response must be concise. 2.82e+08. In the year 1996, what is the difference between the Aid flow (current US$) in Low & middle income and Aid flow (current US$) in Malta?
Make the answer very short. 3.79e+08. In the year 1996, what is the difference between the Aid flow (current US$) of Bosnia and Herzegovina and Aid flow (current US$) of Malta?
Give a very brief answer. 9.68e+07. In the year 1997, what is the difference between the Aid flow (current US$) in Arab World and Aid flow (current US$) in Low & middle income?
Ensure brevity in your answer.  -2.39e+08. In the year 1997, what is the difference between the Aid flow (current US$) of Arab World and Aid flow (current US$) of Bosnia and Herzegovina?
Give a very brief answer. -9.39e+06. In the year 1997, what is the difference between the Aid flow (current US$) of Arab World and Aid flow (current US$) of Malta?
Offer a very short reply. 3.55e+07. In the year 1997, what is the difference between the Aid flow (current US$) of Low & middle income and Aid flow (current US$) of Bosnia and Herzegovina?
Your answer should be compact. 2.30e+08. In the year 1997, what is the difference between the Aid flow (current US$) in Low & middle income and Aid flow (current US$) in Malta?
Your answer should be very brief. 2.75e+08. In the year 1997, what is the difference between the Aid flow (current US$) in Bosnia and Herzegovina and Aid flow (current US$) in Malta?
Your answer should be compact. 4.49e+07. In the year 1998, what is the difference between the Aid flow (current US$) of Arab World and Aid flow (current US$) of Low & middle income?
Your response must be concise. -2.64e+08. In the year 1998, what is the difference between the Aid flow (current US$) in Arab World and Aid flow (current US$) in Malta?
Your answer should be compact. 3.81e+07. In the year 1998, what is the difference between the Aid flow (current US$) of Low & middle income and Aid flow (current US$) of Bosnia and Herzegovina?
Provide a short and direct response. 2.64e+08. In the year 1998, what is the difference between the Aid flow (current US$) of Low & middle income and Aid flow (current US$) of Malta?
Offer a terse response. 3.02e+08. In the year 1998, what is the difference between the Aid flow (current US$) in Bosnia and Herzegovina and Aid flow (current US$) in Malta?
Offer a very short reply. 3.84e+07. In the year 1999, what is the difference between the Aid flow (current US$) of Arab World and Aid flow (current US$) of Low & middle income?
Offer a terse response. -2.82e+08. In the year 1999, what is the difference between the Aid flow (current US$) of Arab World and Aid flow (current US$) of Bosnia and Herzegovina?
Provide a short and direct response. 3.50e+06. In the year 1999, what is the difference between the Aid flow (current US$) in Arab World and Aid flow (current US$) in Malta?
Make the answer very short. 3.20e+07. In the year 1999, what is the difference between the Aid flow (current US$) of Low & middle income and Aid flow (current US$) of Bosnia and Herzegovina?
Your answer should be very brief. 2.86e+08. In the year 1999, what is the difference between the Aid flow (current US$) of Low & middle income and Aid flow (current US$) of Malta?
Provide a succinct answer. 3.14e+08. In the year 1999, what is the difference between the Aid flow (current US$) in Bosnia and Herzegovina and Aid flow (current US$) in Malta?
Offer a very short reply. 2.85e+07. In the year 2000, what is the difference between the Aid flow (current US$) of Arab World and Aid flow (current US$) of Low & middle income?
Your answer should be very brief. -2.45e+08. In the year 2000, what is the difference between the Aid flow (current US$) in Arab World and Aid flow (current US$) in Bosnia and Herzegovina?
Offer a very short reply. 1.26e+07. In the year 2000, what is the difference between the Aid flow (current US$) of Arab World and Aid flow (current US$) of Malta?
Offer a very short reply. 3.50e+07. In the year 2000, what is the difference between the Aid flow (current US$) in Low & middle income and Aid flow (current US$) in Bosnia and Herzegovina?
Ensure brevity in your answer.  2.58e+08. In the year 2000, what is the difference between the Aid flow (current US$) of Low & middle income and Aid flow (current US$) of Malta?
Give a very brief answer. 2.80e+08. In the year 2000, what is the difference between the Aid flow (current US$) in Bosnia and Herzegovina and Aid flow (current US$) in Malta?
Keep it short and to the point. 2.25e+07. In the year 2001, what is the difference between the Aid flow (current US$) in Arab World and Aid flow (current US$) in Low & middle income?
Your answer should be very brief. -4.32e+08. In the year 2001, what is the difference between the Aid flow (current US$) of Arab World and Aid flow (current US$) of Bosnia and Herzegovina?
Your answer should be compact. 1.62e+07. In the year 2001, what is the difference between the Aid flow (current US$) of Arab World and Aid flow (current US$) of Malta?
Ensure brevity in your answer.  3.04e+07. In the year 2001, what is the difference between the Aid flow (current US$) of Low & middle income and Aid flow (current US$) of Bosnia and Herzegovina?
Keep it short and to the point. 4.48e+08. In the year 2001, what is the difference between the Aid flow (current US$) of Low & middle income and Aid flow (current US$) of Malta?
Offer a very short reply. 4.62e+08. In the year 2001, what is the difference between the Aid flow (current US$) of Bosnia and Herzegovina and Aid flow (current US$) of Malta?
Keep it short and to the point. 1.42e+07. What is the ratio of the Aid flow (current US$) in Low & middle income in 1994 to that in 1995?
Your answer should be very brief. 0.5. What is the ratio of the Aid flow (current US$) in Bosnia and Herzegovina in 1994 to that in 1995?
Offer a very short reply. 1.14. What is the ratio of the Aid flow (current US$) in Malta in 1994 to that in 1995?
Your answer should be compact. 8. What is the ratio of the Aid flow (current US$) of Low & middle income in 1994 to that in 1996?
Keep it short and to the point. 0.54. What is the ratio of the Aid flow (current US$) in Bosnia and Herzegovina in 1994 to that in 1996?
Your answer should be compact. 1.27. What is the ratio of the Aid flow (current US$) of Low & middle income in 1994 to that in 1997?
Give a very brief answer. 0.74. What is the ratio of the Aid flow (current US$) in Bosnia and Herzegovina in 1994 to that in 1997?
Provide a short and direct response. 2.74. What is the ratio of the Aid flow (current US$) in Low & middle income in 1994 to that in 1998?
Your answer should be compact. 0.67. What is the ratio of the Aid flow (current US$) of Bosnia and Herzegovina in 1994 to that in 1998?
Your answer should be compact. 3.2. What is the ratio of the Aid flow (current US$) in Malta in 1994 to that in 1998?
Provide a succinct answer. 5.33. What is the ratio of the Aid flow (current US$) of Low & middle income in 1994 to that in 1999?
Provide a short and direct response. 0.65. What is the ratio of the Aid flow (current US$) of Bosnia and Herzegovina in 1994 to that in 1999?
Your answer should be compact. 4.31. What is the ratio of the Aid flow (current US$) of Malta in 1994 to that in 1999?
Provide a short and direct response. 5.33. What is the ratio of the Aid flow (current US$) of Low & middle income in 1994 to that in 2000?
Make the answer very short. 0.72. What is the ratio of the Aid flow (current US$) in Bosnia and Herzegovina in 1994 to that in 2000?
Offer a very short reply. 5.46. What is the ratio of the Aid flow (current US$) in Low & middle income in 1994 to that in 2001?
Make the answer very short. 0.44. What is the ratio of the Aid flow (current US$) in Bosnia and Herzegovina in 1994 to that in 2001?
Make the answer very short. 8.67. What is the ratio of the Aid flow (current US$) of Arab World in 1995 to that in 1996?
Offer a terse response. 1.13. What is the ratio of the Aid flow (current US$) of Low & middle income in 1995 to that in 1996?
Provide a succinct answer. 1.06. What is the ratio of the Aid flow (current US$) of Bosnia and Herzegovina in 1995 to that in 1996?
Give a very brief answer. 1.11. What is the ratio of the Aid flow (current US$) of Malta in 1995 to that in 1996?
Make the answer very short. 0.5. What is the ratio of the Aid flow (current US$) of Arab World in 1995 to that in 1997?
Keep it short and to the point. 1.17. What is the ratio of the Aid flow (current US$) in Low & middle income in 1995 to that in 1997?
Your answer should be compact. 1.47. What is the ratio of the Aid flow (current US$) in Bosnia and Herzegovina in 1995 to that in 1997?
Give a very brief answer. 2.4. What is the ratio of the Aid flow (current US$) of Malta in 1995 to that in 1997?
Provide a short and direct response. 1. What is the ratio of the Aid flow (current US$) of Arab World in 1995 to that in 1998?
Keep it short and to the point. 1.09. What is the ratio of the Aid flow (current US$) in Low & middle income in 1995 to that in 1998?
Your response must be concise. 1.34. What is the ratio of the Aid flow (current US$) of Bosnia and Herzegovina in 1995 to that in 1998?
Your answer should be very brief. 2.8. What is the ratio of the Aid flow (current US$) in Arab World in 1995 to that in 1999?
Provide a short and direct response. 1.3. What is the ratio of the Aid flow (current US$) in Low & middle income in 1995 to that in 1999?
Your answer should be compact. 1.28. What is the ratio of the Aid flow (current US$) of Bosnia and Herzegovina in 1995 to that in 1999?
Ensure brevity in your answer.  3.78. What is the ratio of the Aid flow (current US$) in Arab World in 1995 to that in 2000?
Provide a succinct answer. 1.18. What is the ratio of the Aid flow (current US$) in Low & middle income in 1995 to that in 2000?
Offer a terse response. 1.44. What is the ratio of the Aid flow (current US$) in Bosnia and Herzegovina in 1995 to that in 2000?
Your response must be concise. 4.79. What is the ratio of the Aid flow (current US$) in Arab World in 1995 to that in 2001?
Your answer should be compact. 1.37. What is the ratio of the Aid flow (current US$) of Low & middle income in 1995 to that in 2001?
Ensure brevity in your answer.  0.87. What is the ratio of the Aid flow (current US$) of Bosnia and Herzegovina in 1995 to that in 2001?
Provide a short and direct response. 7.6. What is the ratio of the Aid flow (current US$) of Arab World in 1996 to that in 1997?
Offer a very short reply. 1.03. What is the ratio of the Aid flow (current US$) of Low & middle income in 1996 to that in 1997?
Offer a terse response. 1.38. What is the ratio of the Aid flow (current US$) in Bosnia and Herzegovina in 1996 to that in 1997?
Offer a terse response. 2.15. What is the ratio of the Aid flow (current US$) of Malta in 1996 to that in 1997?
Provide a short and direct response. 2. What is the ratio of the Aid flow (current US$) in Arab World in 1996 to that in 1998?
Offer a very short reply. 0.96. What is the ratio of the Aid flow (current US$) of Low & middle income in 1996 to that in 1998?
Provide a succinct answer. 1.25. What is the ratio of the Aid flow (current US$) of Bosnia and Herzegovina in 1996 to that in 1998?
Provide a succinct answer. 2.52. What is the ratio of the Aid flow (current US$) of Arab World in 1996 to that in 1999?
Provide a succinct answer. 1.15. What is the ratio of the Aid flow (current US$) of Low & middle income in 1996 to that in 1999?
Give a very brief answer. 1.21. What is the ratio of the Aid flow (current US$) in Bosnia and Herzegovina in 1996 to that in 1999?
Your response must be concise. 3.39. What is the ratio of the Aid flow (current US$) in Malta in 1996 to that in 1999?
Offer a very short reply. 1.33. What is the ratio of the Aid flow (current US$) of Arab World in 1996 to that in 2000?
Provide a succinct answer. 1.05. What is the ratio of the Aid flow (current US$) in Low & middle income in 1996 to that in 2000?
Your answer should be compact. 1.35. What is the ratio of the Aid flow (current US$) of Bosnia and Herzegovina in 1996 to that in 2000?
Provide a succinct answer. 4.3. What is the ratio of the Aid flow (current US$) of Arab World in 1996 to that in 2001?
Ensure brevity in your answer.  1.21. What is the ratio of the Aid flow (current US$) of Low & middle income in 1996 to that in 2001?
Your answer should be compact. 0.82. What is the ratio of the Aid flow (current US$) of Bosnia and Herzegovina in 1996 to that in 2001?
Your answer should be very brief. 6.82. What is the ratio of the Aid flow (current US$) of Arab World in 1997 to that in 1998?
Keep it short and to the point. 0.93. What is the ratio of the Aid flow (current US$) of Low & middle income in 1997 to that in 1998?
Your answer should be very brief. 0.91. What is the ratio of the Aid flow (current US$) in Bosnia and Herzegovina in 1997 to that in 1998?
Make the answer very short. 1.17. What is the ratio of the Aid flow (current US$) in Arab World in 1997 to that in 1999?
Provide a succinct answer. 1.11. What is the ratio of the Aid flow (current US$) in Low & middle income in 1997 to that in 1999?
Keep it short and to the point. 0.87. What is the ratio of the Aid flow (current US$) in Bosnia and Herzegovina in 1997 to that in 1999?
Your answer should be compact. 1.58. What is the ratio of the Aid flow (current US$) of Arab World in 1997 to that in 2000?
Offer a very short reply. 1.01. What is the ratio of the Aid flow (current US$) of Low & middle income in 1997 to that in 2000?
Give a very brief answer. 0.98. What is the ratio of the Aid flow (current US$) of Bosnia and Herzegovina in 1997 to that in 2000?
Offer a terse response. 2. What is the ratio of the Aid flow (current US$) in Arab World in 1997 to that in 2001?
Offer a very short reply. 1.17. What is the ratio of the Aid flow (current US$) in Low & middle income in 1997 to that in 2001?
Provide a succinct answer. 0.59. What is the ratio of the Aid flow (current US$) in Bosnia and Herzegovina in 1997 to that in 2001?
Your response must be concise. 3.17. What is the ratio of the Aid flow (current US$) of Arab World in 1998 to that in 1999?
Give a very brief answer. 1.19. What is the ratio of the Aid flow (current US$) in Low & middle income in 1998 to that in 1999?
Your response must be concise. 0.96. What is the ratio of the Aid flow (current US$) of Bosnia and Herzegovina in 1998 to that in 1999?
Your answer should be compact. 1.35. What is the ratio of the Aid flow (current US$) of Arab World in 1998 to that in 2000?
Offer a terse response. 1.09. What is the ratio of the Aid flow (current US$) in Low & middle income in 1998 to that in 2000?
Provide a succinct answer. 1.08. What is the ratio of the Aid flow (current US$) in Bosnia and Herzegovina in 1998 to that in 2000?
Your response must be concise. 1.71. What is the ratio of the Aid flow (current US$) in Malta in 1998 to that in 2000?
Your answer should be very brief. 1.5. What is the ratio of the Aid flow (current US$) in Arab World in 1998 to that in 2001?
Your answer should be very brief. 1.26. What is the ratio of the Aid flow (current US$) of Low & middle income in 1998 to that in 2001?
Ensure brevity in your answer.  0.65. What is the ratio of the Aid flow (current US$) of Bosnia and Herzegovina in 1998 to that in 2001?
Keep it short and to the point. 2.71. What is the ratio of the Aid flow (current US$) in Malta in 1998 to that in 2001?
Keep it short and to the point. 3. What is the ratio of the Aid flow (current US$) in Arab World in 1999 to that in 2000?
Give a very brief answer. 0.91. What is the ratio of the Aid flow (current US$) in Low & middle income in 1999 to that in 2000?
Ensure brevity in your answer.  1.12. What is the ratio of the Aid flow (current US$) in Bosnia and Herzegovina in 1999 to that in 2000?
Give a very brief answer. 1.27. What is the ratio of the Aid flow (current US$) in Arab World in 1999 to that in 2001?
Your answer should be compact. 1.05. What is the ratio of the Aid flow (current US$) in Low & middle income in 1999 to that in 2001?
Offer a very short reply. 0.68. What is the ratio of the Aid flow (current US$) in Bosnia and Herzegovina in 1999 to that in 2001?
Make the answer very short. 2.01. What is the ratio of the Aid flow (current US$) of Malta in 1999 to that in 2001?
Provide a short and direct response. 3. What is the ratio of the Aid flow (current US$) in Arab World in 2000 to that in 2001?
Offer a very short reply. 1.16. What is the ratio of the Aid flow (current US$) of Low & middle income in 2000 to that in 2001?
Your answer should be very brief. 0.61. What is the ratio of the Aid flow (current US$) in Bosnia and Herzegovina in 2000 to that in 2001?
Provide a succinct answer. 1.59. What is the difference between the highest and the second highest Aid flow (current US$) in Arab World?
Offer a very short reply. 3.39e+06. What is the difference between the highest and the second highest Aid flow (current US$) of Low & middle income?
Offer a terse response. 5.89e+07. What is the difference between the highest and the second highest Aid flow (current US$) of Bosnia and Herzegovina?
Ensure brevity in your answer.  1.51e+07. What is the difference between the highest and the lowest Aid flow (current US$) of Arab World?
Provide a short and direct response. 4.15e+07. What is the difference between the highest and the lowest Aid flow (current US$) of Low & middle income?
Keep it short and to the point. 2.59e+08. What is the difference between the highest and the lowest Aid flow (current US$) in Bosnia and Herzegovina?
Keep it short and to the point. 1.09e+08. What is the difference between the highest and the lowest Aid flow (current US$) in Malta?
Your answer should be very brief. 1.50e+05. 